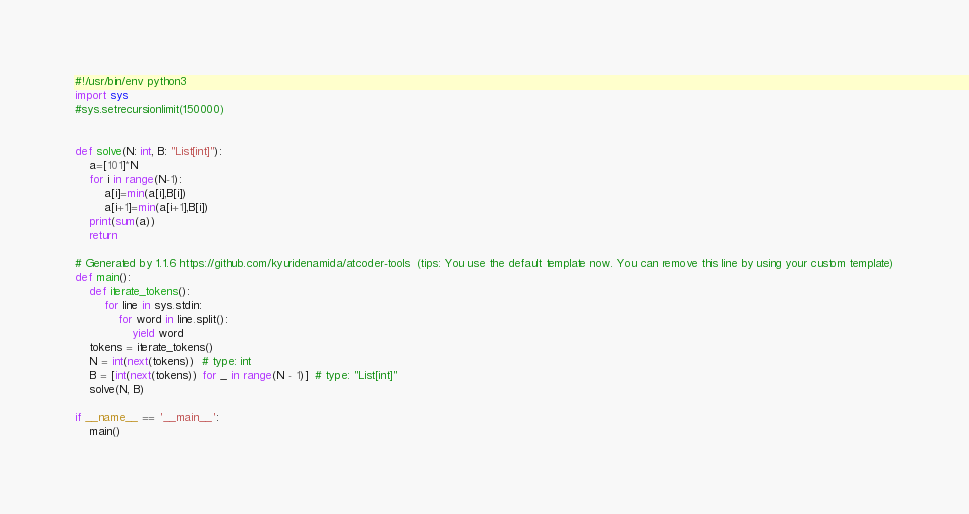Convert code to text. <code><loc_0><loc_0><loc_500><loc_500><_Python_>#!/usr/bin/env python3
import sys
#sys.setrecursionlimit(150000)


def solve(N: int, B: "List[int]"):
    a=[101]*N
    for i in range(N-1):
        a[i]=min(a[i],B[i])
        a[i+1]=min(a[i+1],B[i])
    print(sum(a))
    return

# Generated by 1.1.6 https://github.com/kyuridenamida/atcoder-tools  (tips: You use the default template now. You can remove this line by using your custom template)
def main():
    def iterate_tokens():
        for line in sys.stdin:
            for word in line.split():
                yield word
    tokens = iterate_tokens()
    N = int(next(tokens))  # type: int
    B = [int(next(tokens)) for _ in range(N - 1)]  # type: "List[int]"
    solve(N, B)

if __name__ == '__main__':
    main()
</code> 